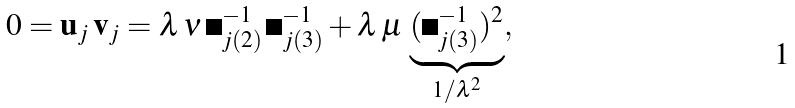Convert formula to latex. <formula><loc_0><loc_0><loc_500><loc_500>0 = { \mathbf u } _ { j } \, { \mathbf v } _ { j } = \lambda \, \nu \, { \mathbf \Psi } ^ { - 1 } _ { j ( 2 ) } \, { \mathbf \Psi } ^ { - 1 } _ { j ( 3 ) } + \lambda \, \mu \, \underbrace { ( { \mathbf \Psi } ^ { - 1 } _ { j ( 3 ) } ) ^ { 2 } } _ { 1 / \lambda ^ { 2 } } ,</formula> 